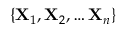<formula> <loc_0><loc_0><loc_500><loc_500>\{ X _ { 1 } , X _ { 2 } , \dots X _ { n } \}</formula> 